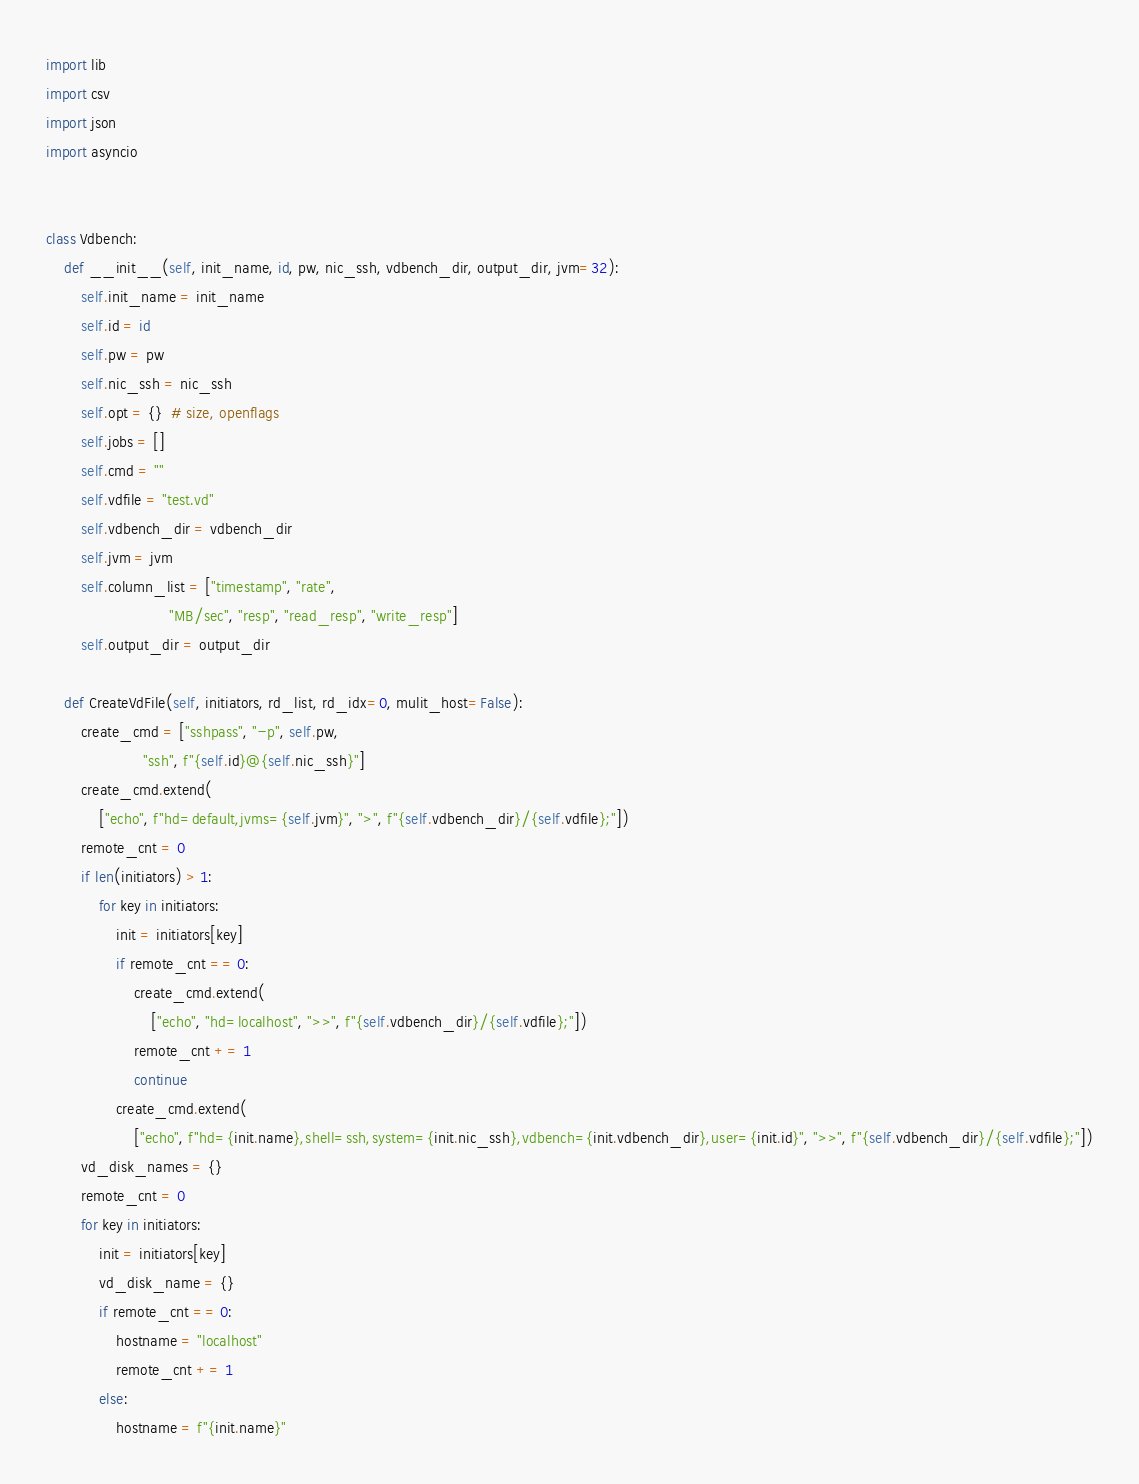<code> <loc_0><loc_0><loc_500><loc_500><_Python_>import lib
import csv
import json
import asyncio


class Vdbench:
    def __init__(self, init_name, id, pw, nic_ssh, vdbench_dir, output_dir, jvm=32):
        self.init_name = init_name
        self.id = id
        self.pw = pw
        self.nic_ssh = nic_ssh
        self.opt = {}  # size, openflags
        self.jobs = []
        self.cmd = ""
        self.vdfile = "test.vd"
        self.vdbench_dir = vdbench_dir
        self.jvm = jvm
        self.column_list = ["timestamp", "rate",
                            "MB/sec", "resp", "read_resp", "write_resp"]
        self.output_dir = output_dir

    def CreateVdFile(self, initiators, rd_list, rd_idx=0, mulit_host=False):
        create_cmd = ["sshpass", "-p", self.pw,
                      "ssh", f"{self.id}@{self.nic_ssh}"]
        create_cmd.extend(
            ["echo", f"hd=default,jvms={self.jvm}", ">", f"{self.vdbench_dir}/{self.vdfile};"])
        remote_cnt = 0
        if len(initiators) > 1:
            for key in initiators:
                init = initiators[key]
                if remote_cnt == 0:
                    create_cmd.extend(
                        ["echo", "hd=localhost", ">>", f"{self.vdbench_dir}/{self.vdfile};"])
                    remote_cnt += 1
                    continue
                create_cmd.extend(
                    ["echo", f"hd={init.name},shell=ssh,system={init.nic_ssh},vdbench={init.vdbench_dir},user={init.id}", ">>", f"{self.vdbench_dir}/{self.vdfile};"])
        vd_disk_names = {}
        remote_cnt = 0
        for key in initiators:
            init = initiators[key]
            vd_disk_name = {}
            if remote_cnt == 0:
                hostname = "localhost"
                remote_cnt += 1
            else:
                hostname = f"{init.name}"</code> 